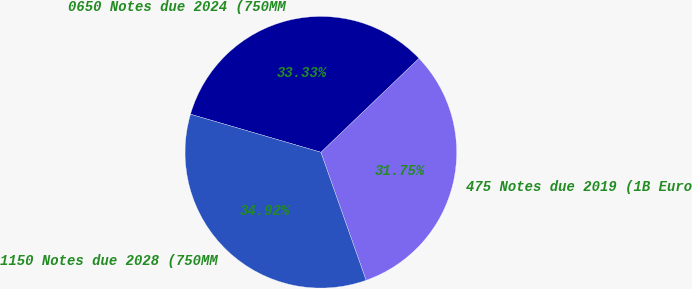Convert chart to OTSL. <chart><loc_0><loc_0><loc_500><loc_500><pie_chart><fcel>475 Notes due 2019 (1B Euro<fcel>0650 Notes due 2024 (750MM<fcel>1150 Notes due 2028 (750MM<nl><fcel>31.75%<fcel>33.33%<fcel>34.92%<nl></chart> 